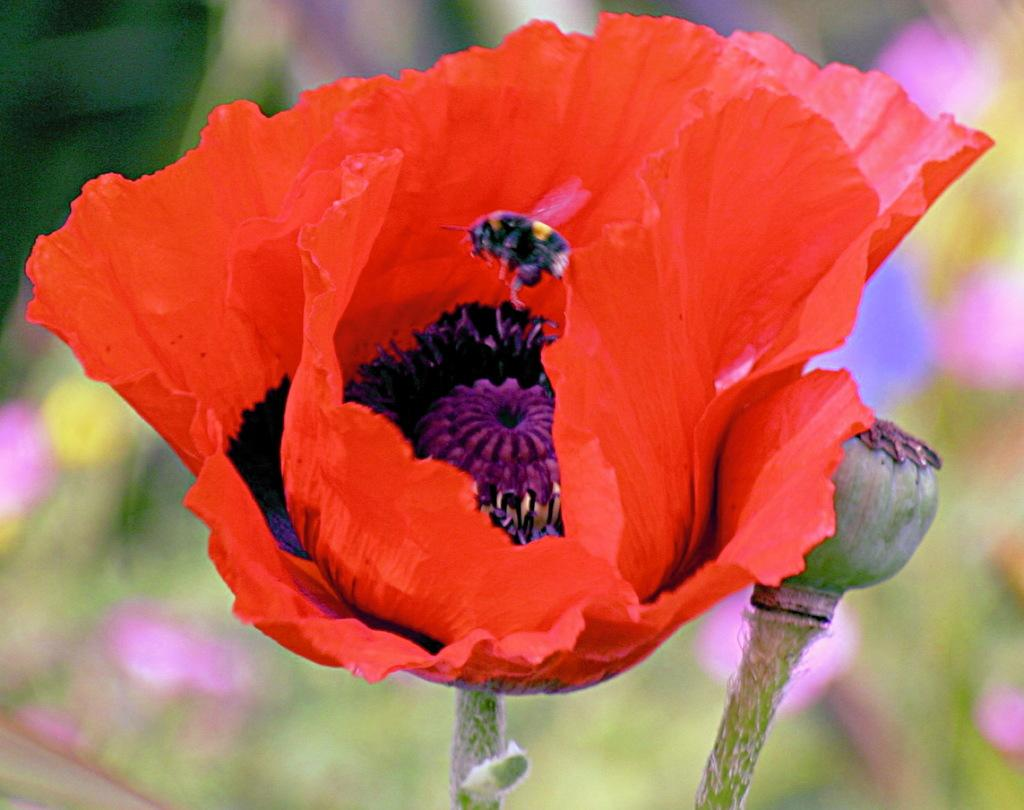What type of flowers are present in the image? There are red color flowers in the image. Can you describe any other features of the flowers? There is a bud along with the stems in the image. What is present on one of the flowers? There is a bee on the flower. How would you describe the background of the image? The background of the image is blurred. What position does the duck hold in the image? There is no duck present in the image. How does the camera capture the image? The camera is not visible in the image, so we cannot determine how it captures the image. 